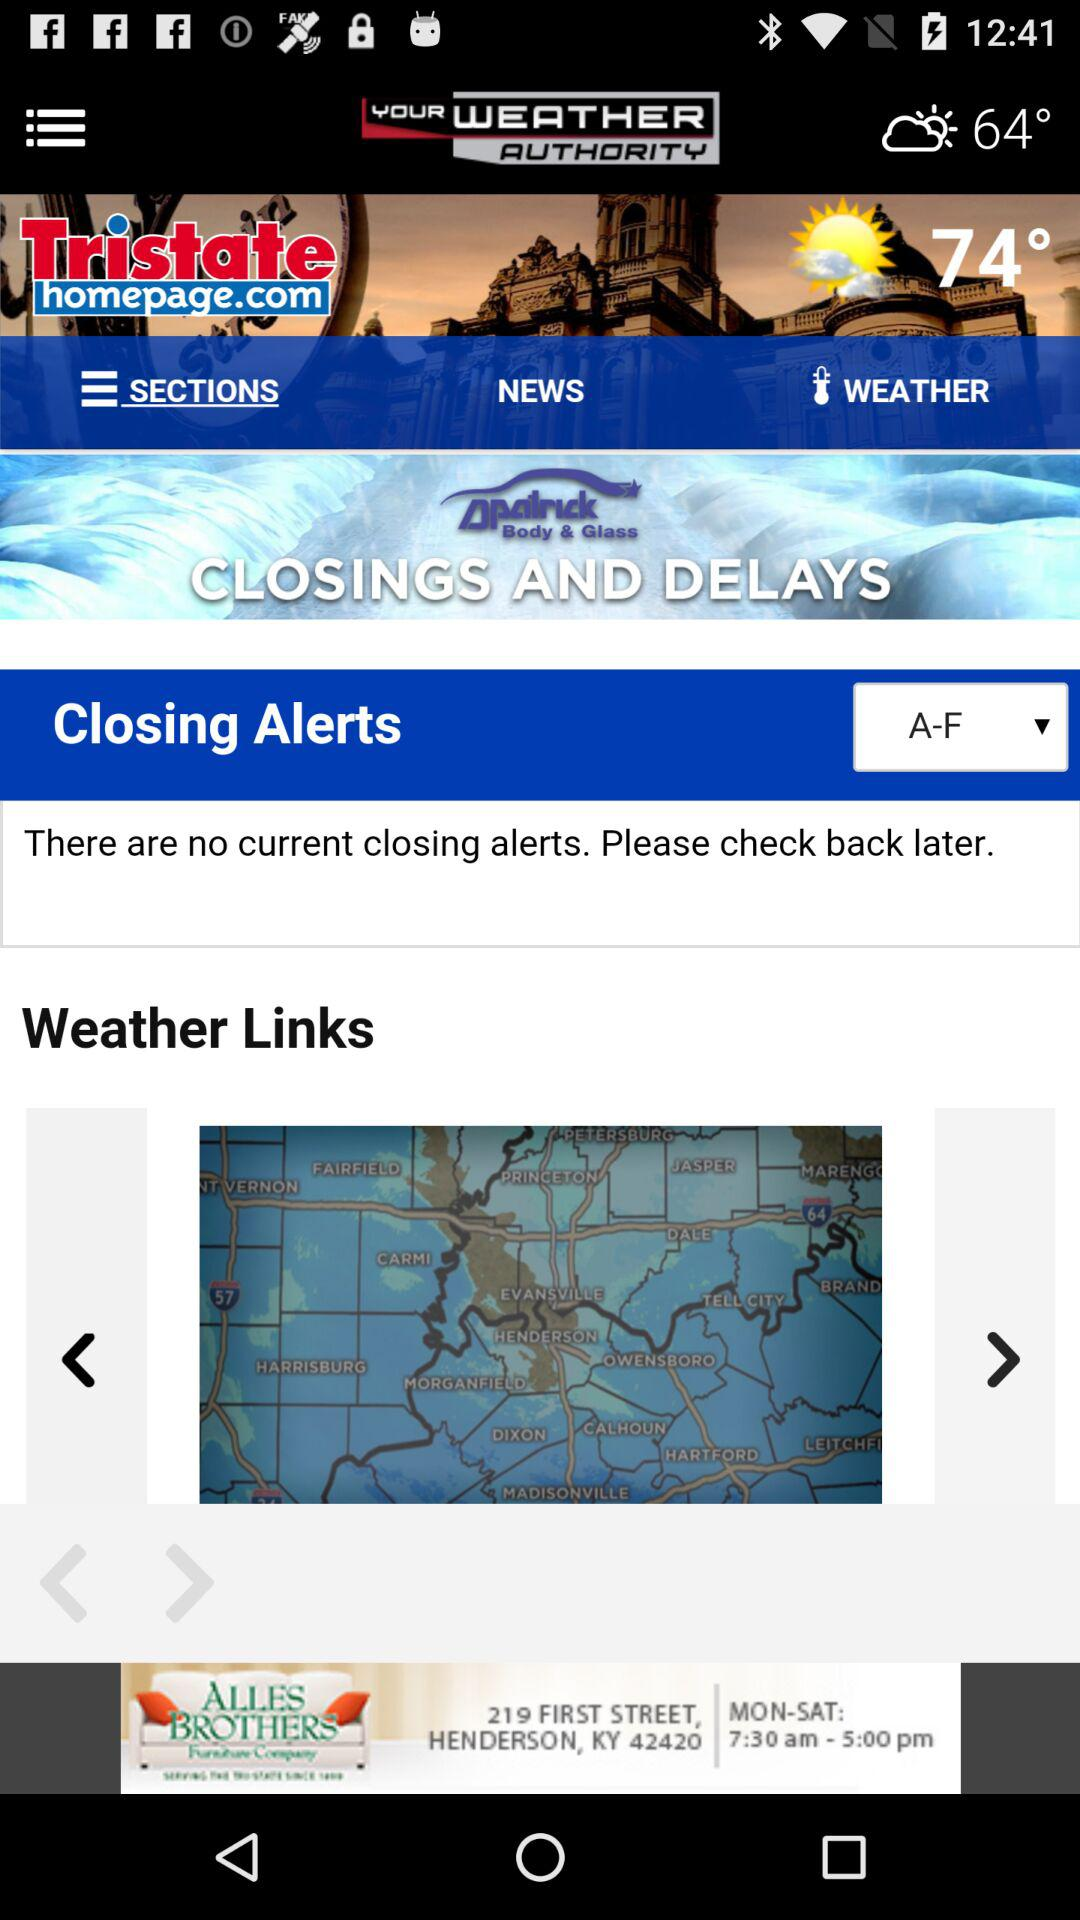What is the current temperature? The current temperature is 64°. 